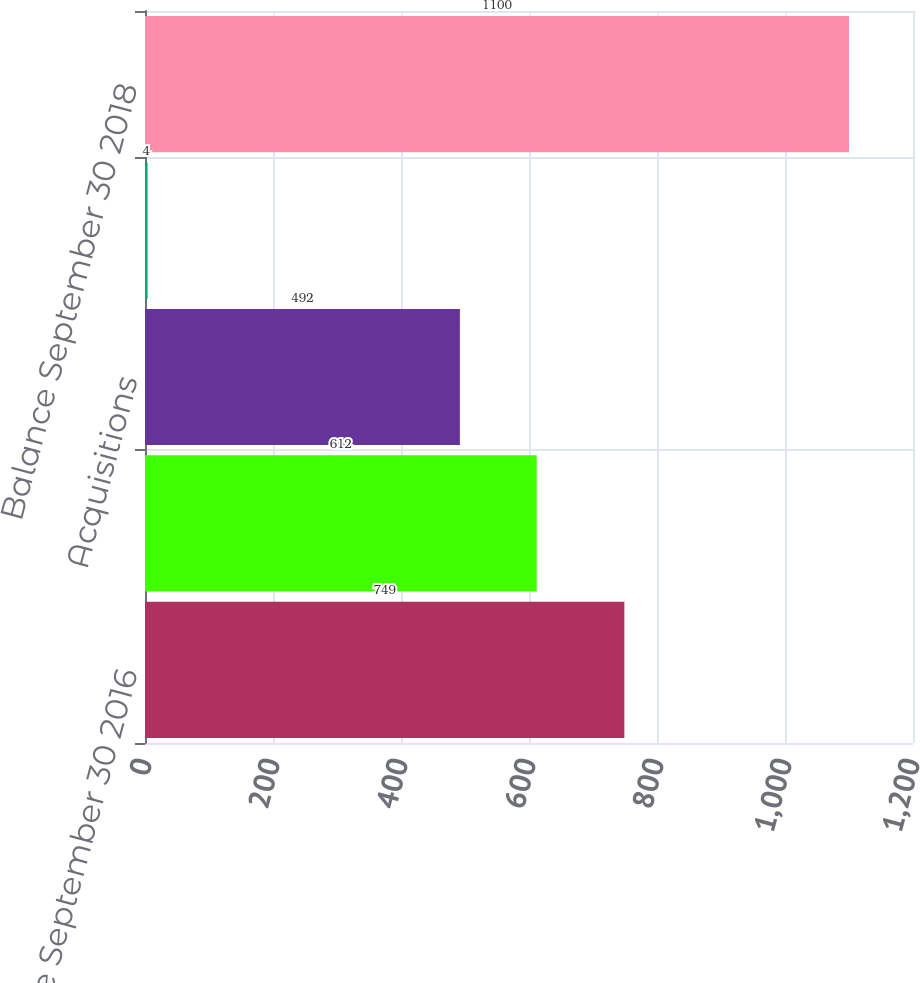Convert chart to OTSL. <chart><loc_0><loc_0><loc_500><loc_500><bar_chart><fcel>Balance September 30 2016<fcel>Balance September 30 2017<fcel>Acquisitions<fcel>Foreign currency translation<fcel>Balance September 30 2018<nl><fcel>749<fcel>612<fcel>492<fcel>4<fcel>1100<nl></chart> 